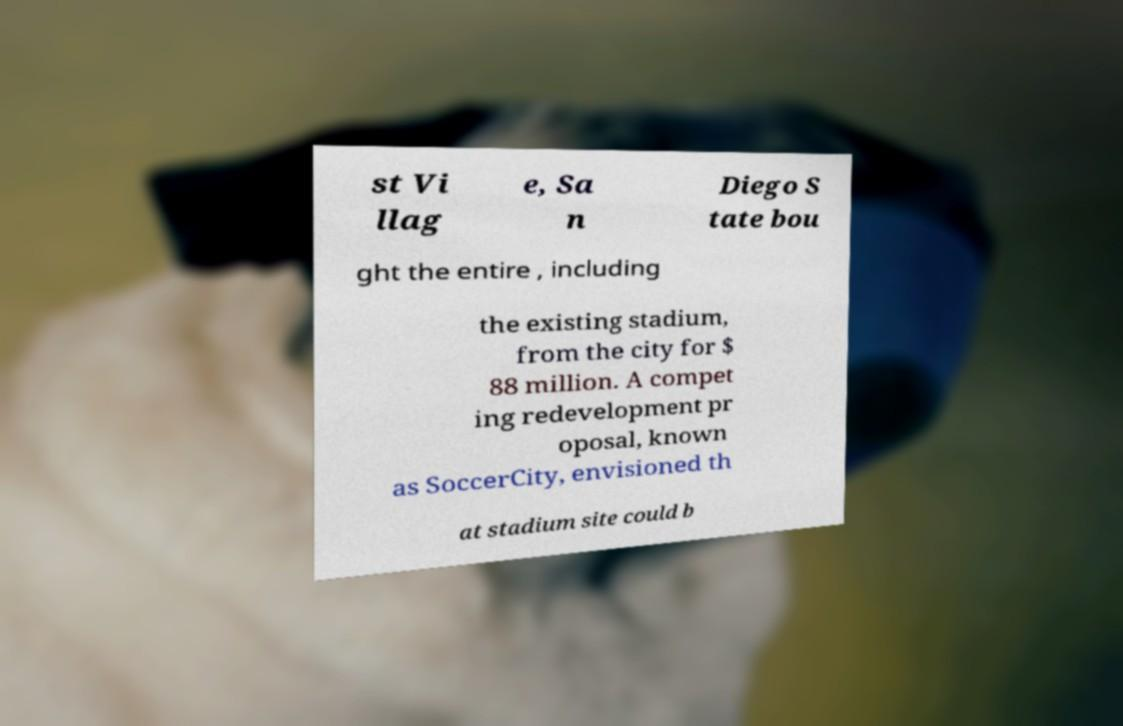Could you extract and type out the text from this image? st Vi llag e, Sa n Diego S tate bou ght the entire , including the existing stadium, from the city for $ 88 million. A compet ing redevelopment pr oposal, known as SoccerCity, envisioned th at stadium site could b 